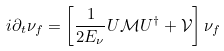<formula> <loc_0><loc_0><loc_500><loc_500>i \partial _ { t } \nu _ { f } = \left [ \frac { 1 } { 2 E _ { \nu } } U \mathcal { M } U ^ { \dagger } + \mathcal { V } \right ] \nu _ { f }</formula> 